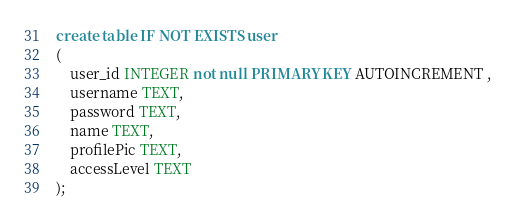<code> <loc_0><loc_0><loc_500><loc_500><_SQL_>create table IF NOT EXISTS user
(
    user_id INTEGER not null PRIMARY KEY AUTOINCREMENT ,
    username TEXT,
    password TEXT,
    name TEXT,
    profilePic TEXT,
    accessLevel TEXT
);</code> 